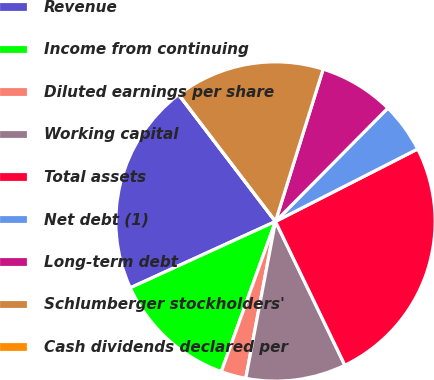Convert chart. <chart><loc_0><loc_0><loc_500><loc_500><pie_chart><fcel>Revenue<fcel>Income from continuing<fcel>Diluted earnings per share<fcel>Working capital<fcel>Total assets<fcel>Net debt (1)<fcel>Long-term debt<fcel>Schlumberger stockholders'<fcel>Cash dividends declared per<nl><fcel>21.45%<fcel>12.67%<fcel>2.53%<fcel>10.14%<fcel>25.34%<fcel>5.07%<fcel>7.6%<fcel>15.2%<fcel>0.0%<nl></chart> 